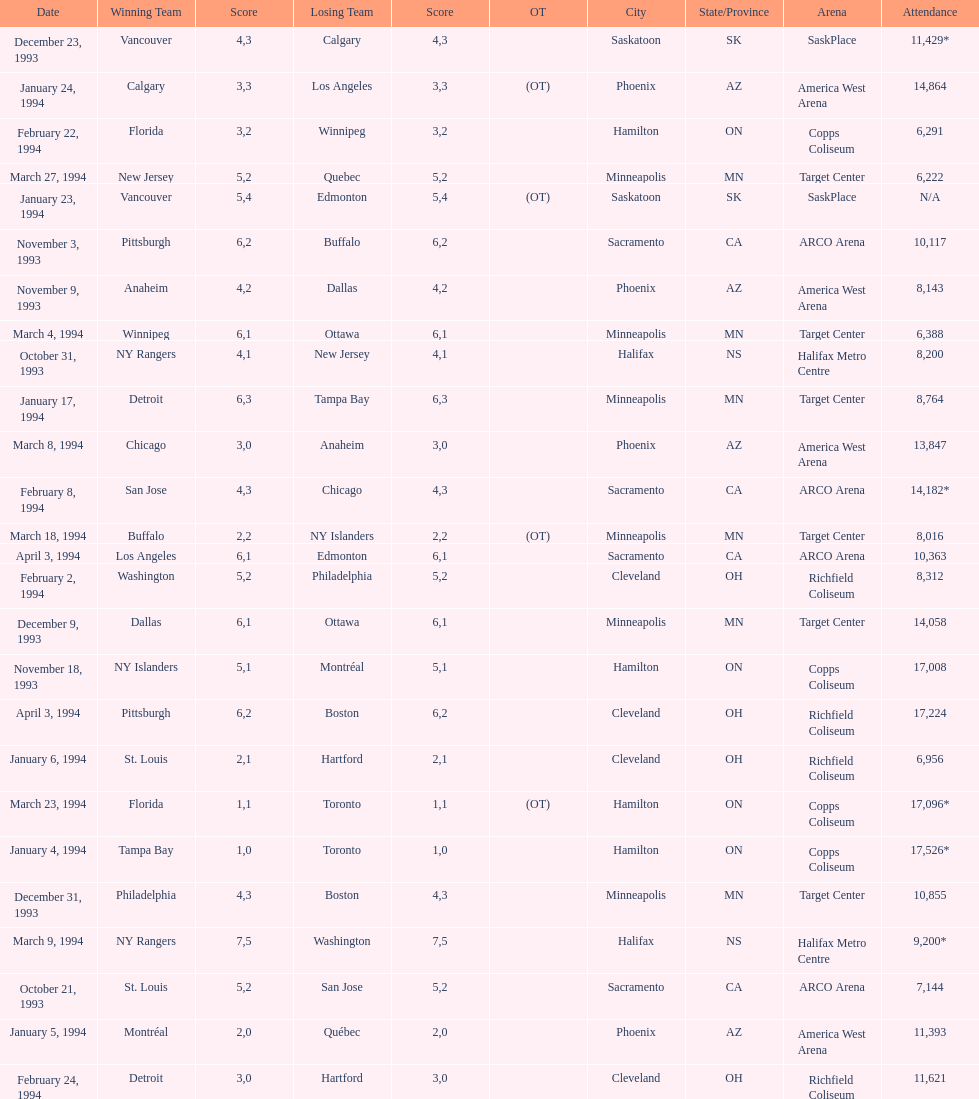Which event had higher attendance, january 24, 1994, or december 23, 1993? January 4, 1994. 